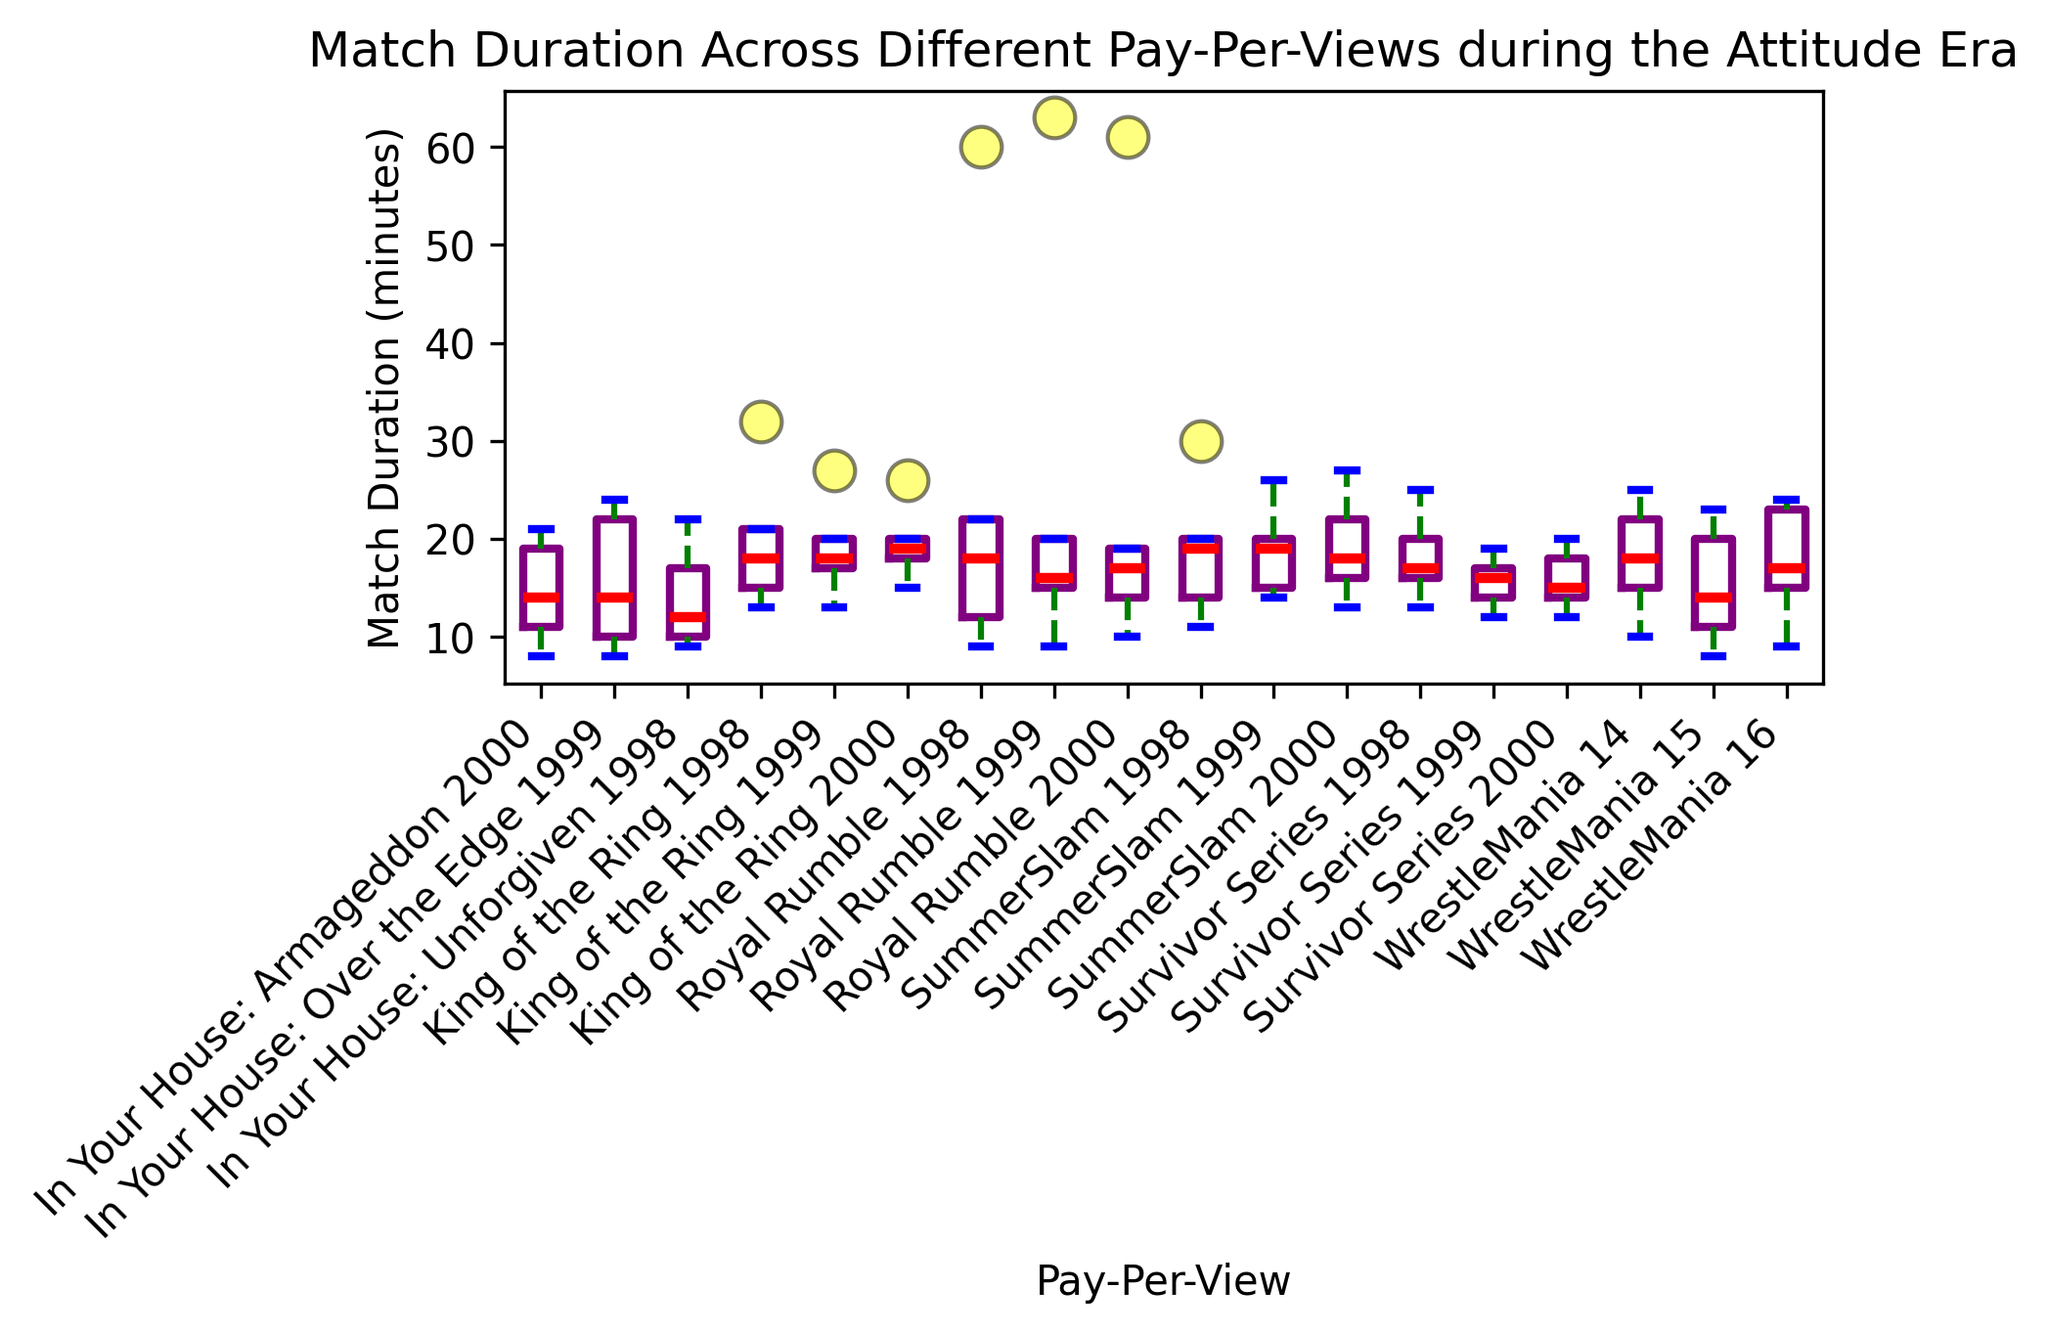What's the median match duration for Royal Rumble 1998? The median is the middle value when the data points are arranged in order. Organizing the match durations for Royal Rumble 1998 (9, 12, 18, 22, 60), the median value is 18 as it is the middle number.
Answer: 18 Which pay-per-view has the highest median match duration? To find the highest median match duration, compare the median values of all the pay-per-views. The highest medians will visually appear as those with higher red lines (indicative of median). WrestleMania 14 has the highest median value.
Answer: WrestleMania 14 Are there any pay-per-views with at least one match duration above 50 minutes? Look at the top of each box plot for any outliers (flier points) above 50 minutes. Royal Rumble 1998 and Royal Rumble 1999 have matches that are above 50 minutes.
Answer: Yes Which pay-per-view has the smallest range of match durations? The range is the difference between the longest and shortest match durations. Visualize the vertical span of the whiskers for each box plot and identify the smallest vertical range. In Your House: Over the Edge 1999 appears to have the smallest range.
Answer: In Your House: Over the Edge 1999 How does the median match duration of WrestleMania 16 compare to WrestleMania 14? Compare the positions of the median lines (red) for both WrestleMania 16 and WrestleMania 14. WrestleMania 14 has a higher median than WrestleMania 16.
Answer: WrestleMania 14 > WrestleMania 16 What's the interquartile range (IQR) for SummerSlam 1998? The IQR is the range between the first quartile (Q1) and the third quartile (Q3). Visualize the lower and upper edges of the box for SummerSlam 1998 and measure the span. If Q1 is 14 and Q3 is 20, then IQR = 20 - 14.
Answer: 6 Which pay-per-view has the most consistent match durations (smallest deviations from the median)? Look for the shortest box and whisker lengths, which indicate less variation. In Your House: Over the Edge 1999 appears to have the most consistent (small deviations) match durations.
Answer: In Your House: Over the Edge 1999 How does the range of match durations for King of the Ring 1998 compare to King of the Ring 1999? Calculate the range for both pay-per-views. King of the Ring 1998: 32-13 = 19. King of the Ring 1999: 27-13 = 14. King of the Ring 1998 has a larger range.
Answer: King of the Ring 1998 > King of the Ring 1999 